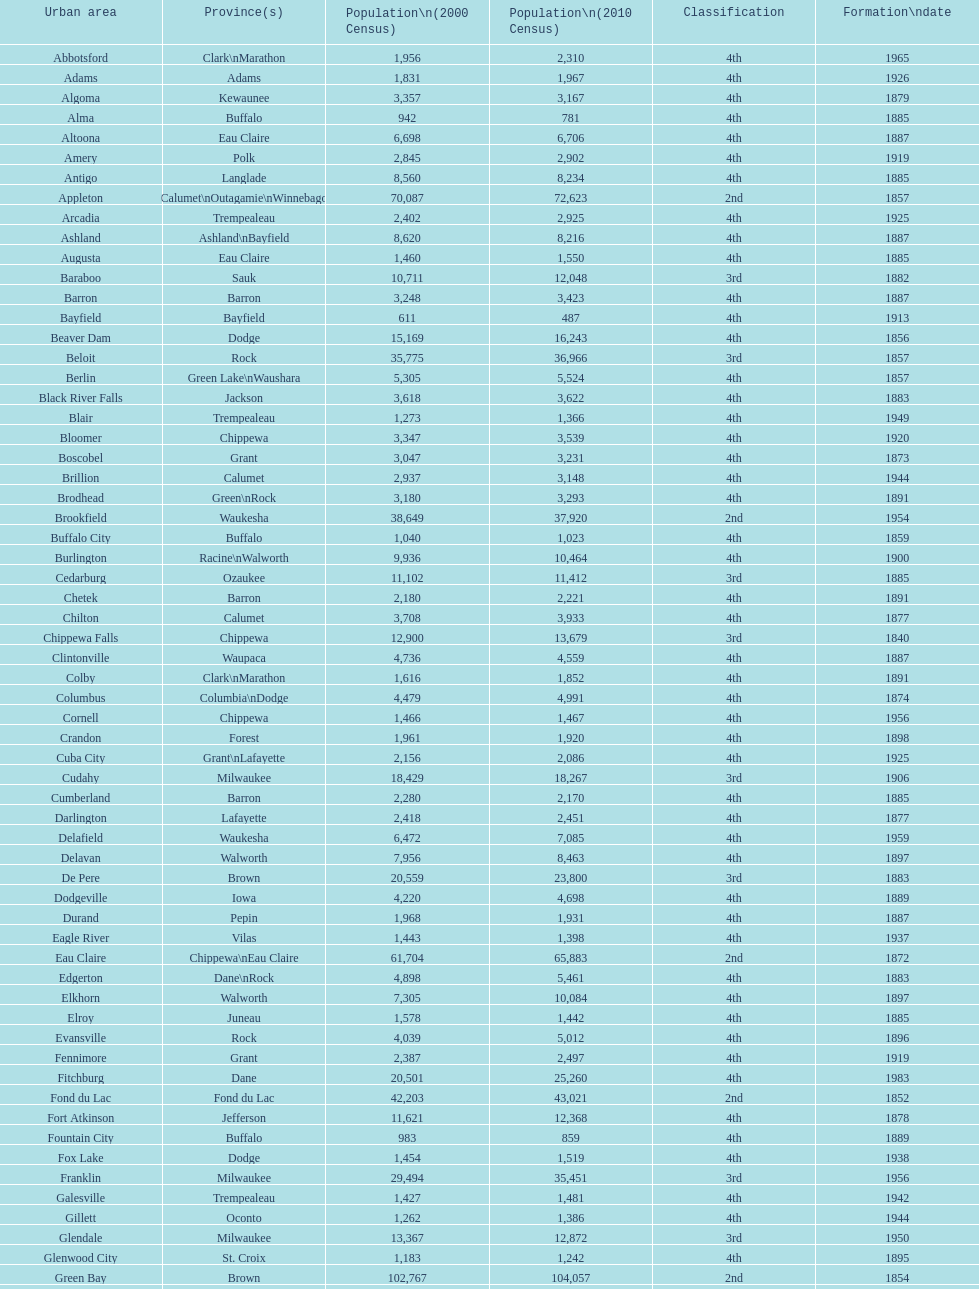What was the first city to be incorporated into wisconsin? Chippewa Falls. 